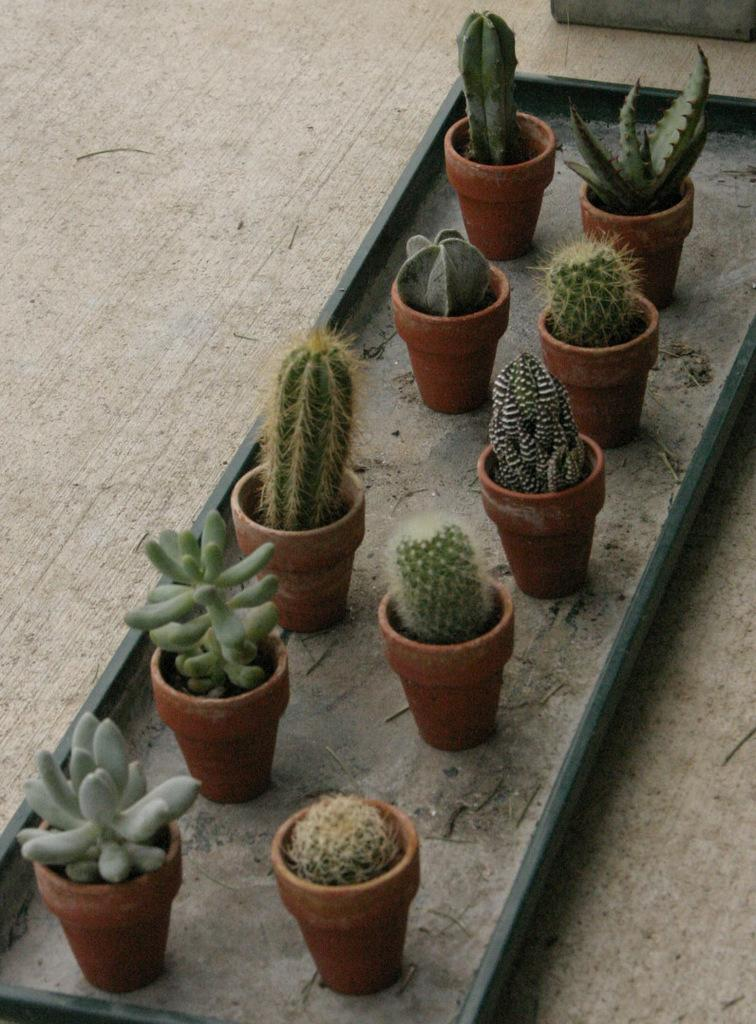What object can be seen in the image that is used for holding or carrying items? There is a tray in the image that can be used for holding or carrying items. What is hanging from the tree in the image? There are pots on a tree in the image. What type of plants are present on a post in the image? There are desert plants on a post in the image. What type of paste is being used to create knowledge in the image? There is no paste or knowledge being created in the image; it features a tray, pots on a tree, and desert plants on a post. 